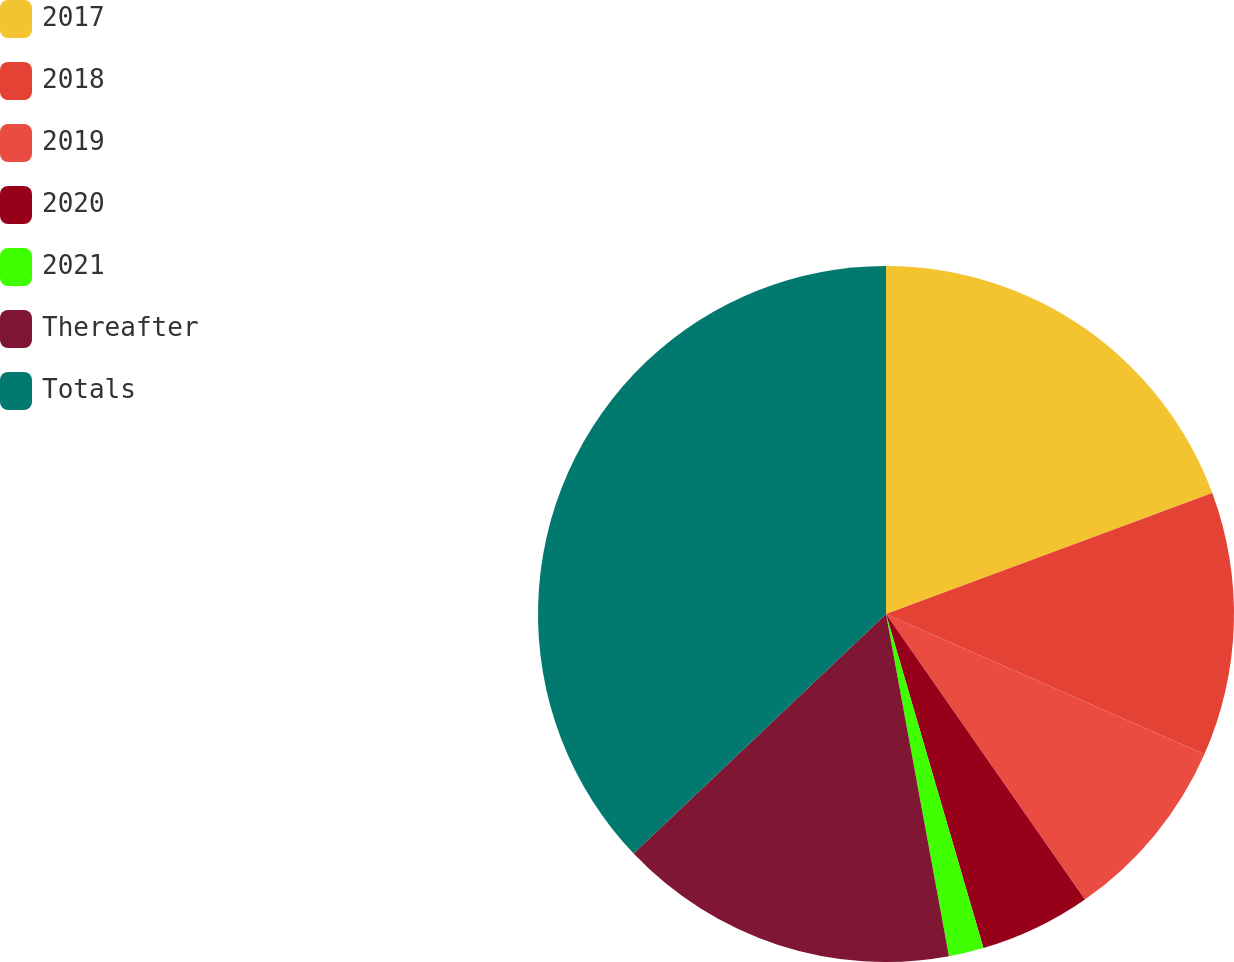Convert chart to OTSL. <chart><loc_0><loc_0><loc_500><loc_500><pie_chart><fcel>2017<fcel>2018<fcel>2019<fcel>2020<fcel>2021<fcel>Thereafter<fcel>Totals<nl><fcel>19.35%<fcel>12.26%<fcel>8.71%<fcel>5.17%<fcel>1.62%<fcel>15.81%<fcel>37.09%<nl></chart> 